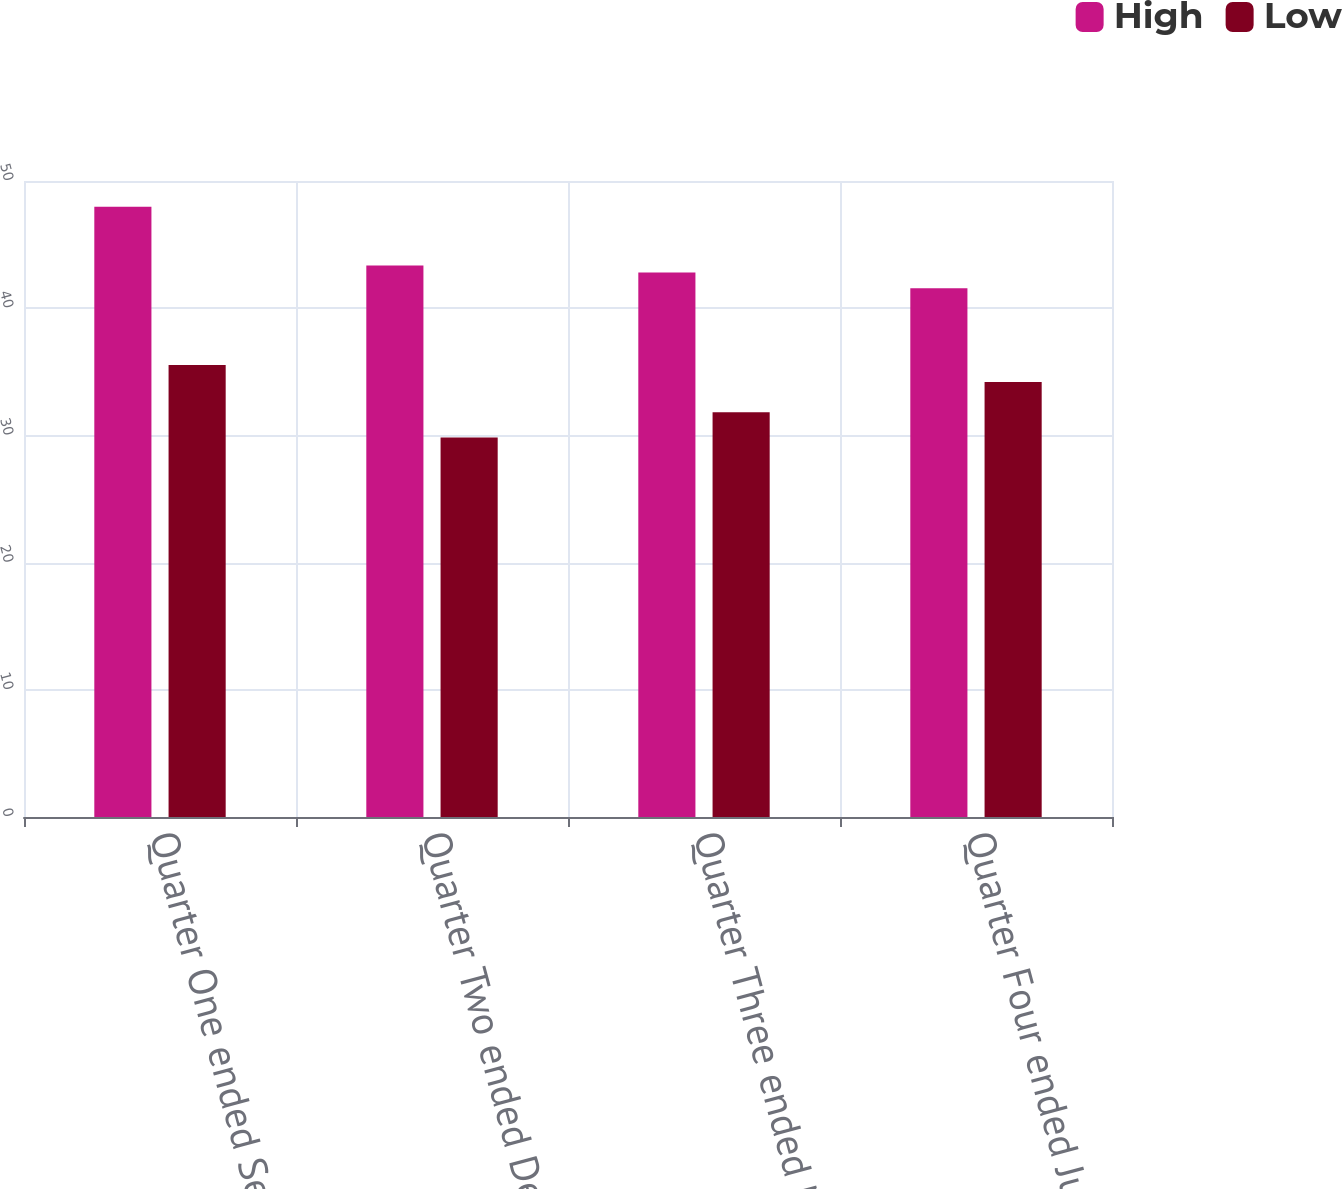<chart> <loc_0><loc_0><loc_500><loc_500><stacked_bar_chart><ecel><fcel>Quarter One ended September 30<fcel>Quarter Two ended December 31<fcel>Quarter Three ended March 31<fcel>Quarter Four ended June 30<nl><fcel>High<fcel>47.98<fcel>43.35<fcel>42.81<fcel>41.56<nl><fcel>Low<fcel>35.53<fcel>29.83<fcel>31.82<fcel>34.19<nl></chart> 